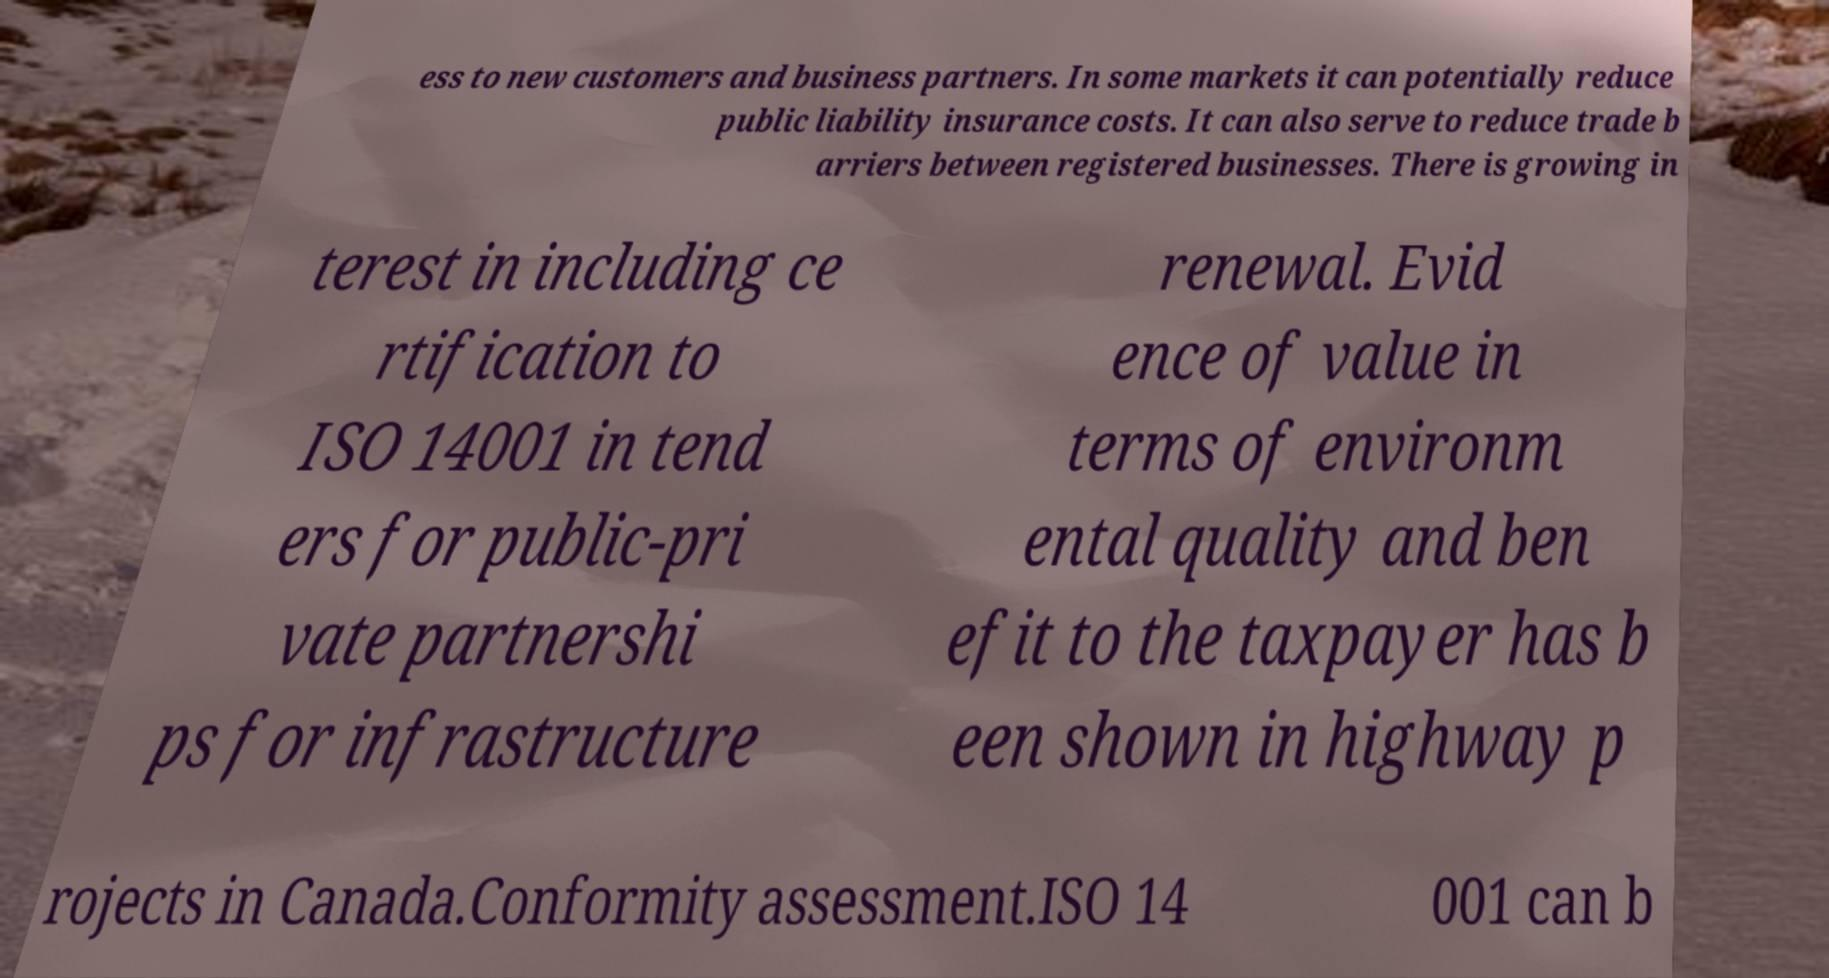Could you extract and type out the text from this image? ess to new customers and business partners. In some markets it can potentially reduce public liability insurance costs. It can also serve to reduce trade b arriers between registered businesses. There is growing in terest in including ce rtification to ISO 14001 in tend ers for public-pri vate partnershi ps for infrastructure renewal. Evid ence of value in terms of environm ental quality and ben efit to the taxpayer has b een shown in highway p rojects in Canada.Conformity assessment.ISO 14 001 can b 